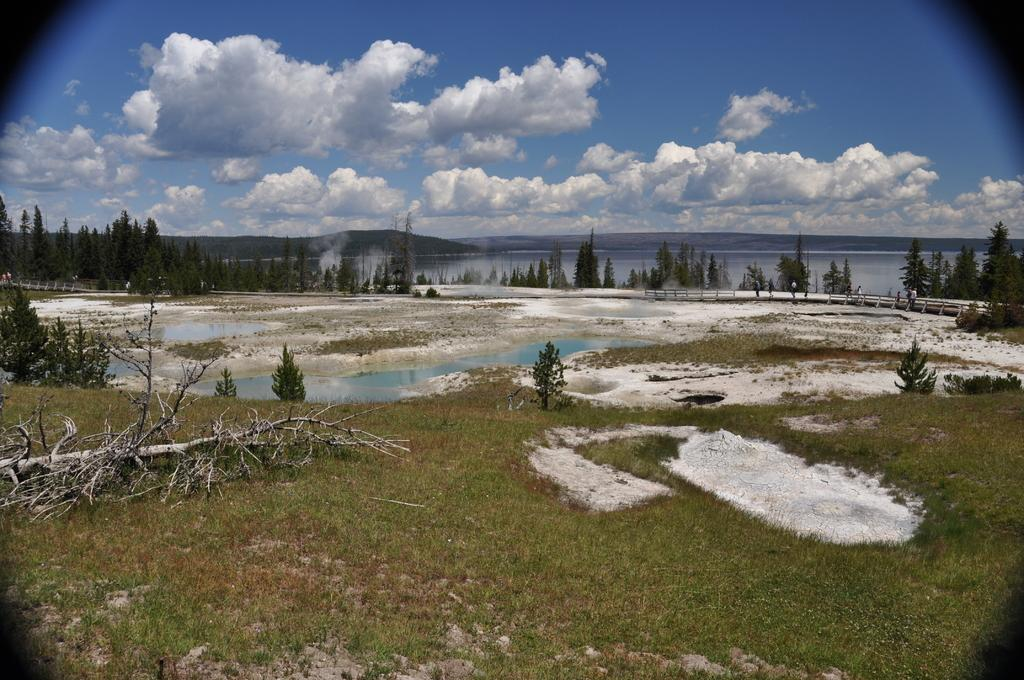What type of ground surface is visible in the image? The ground in the image is covered with grass. What natural elements can be seen in the image? There are many trees and water on the ground in the image. How would you describe the sky in the image? The sky in the image is cloudy. What type of appliance is being used to create the veil of mist in the image? There is no appliance or veil of mist present in the image. What act is being performed by the trees in the image? The trees in the image are not performing any act; they are simply standing in their natural state. 